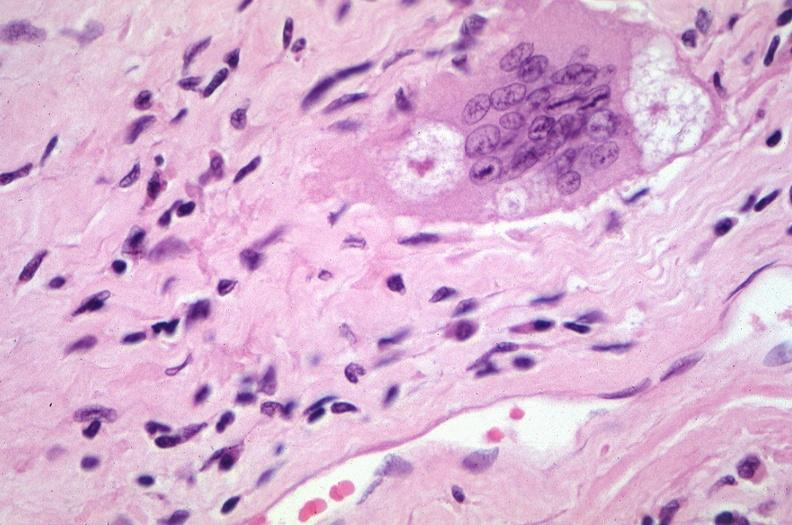s respiratory present?
Answer the question using a single word or phrase. Yes 